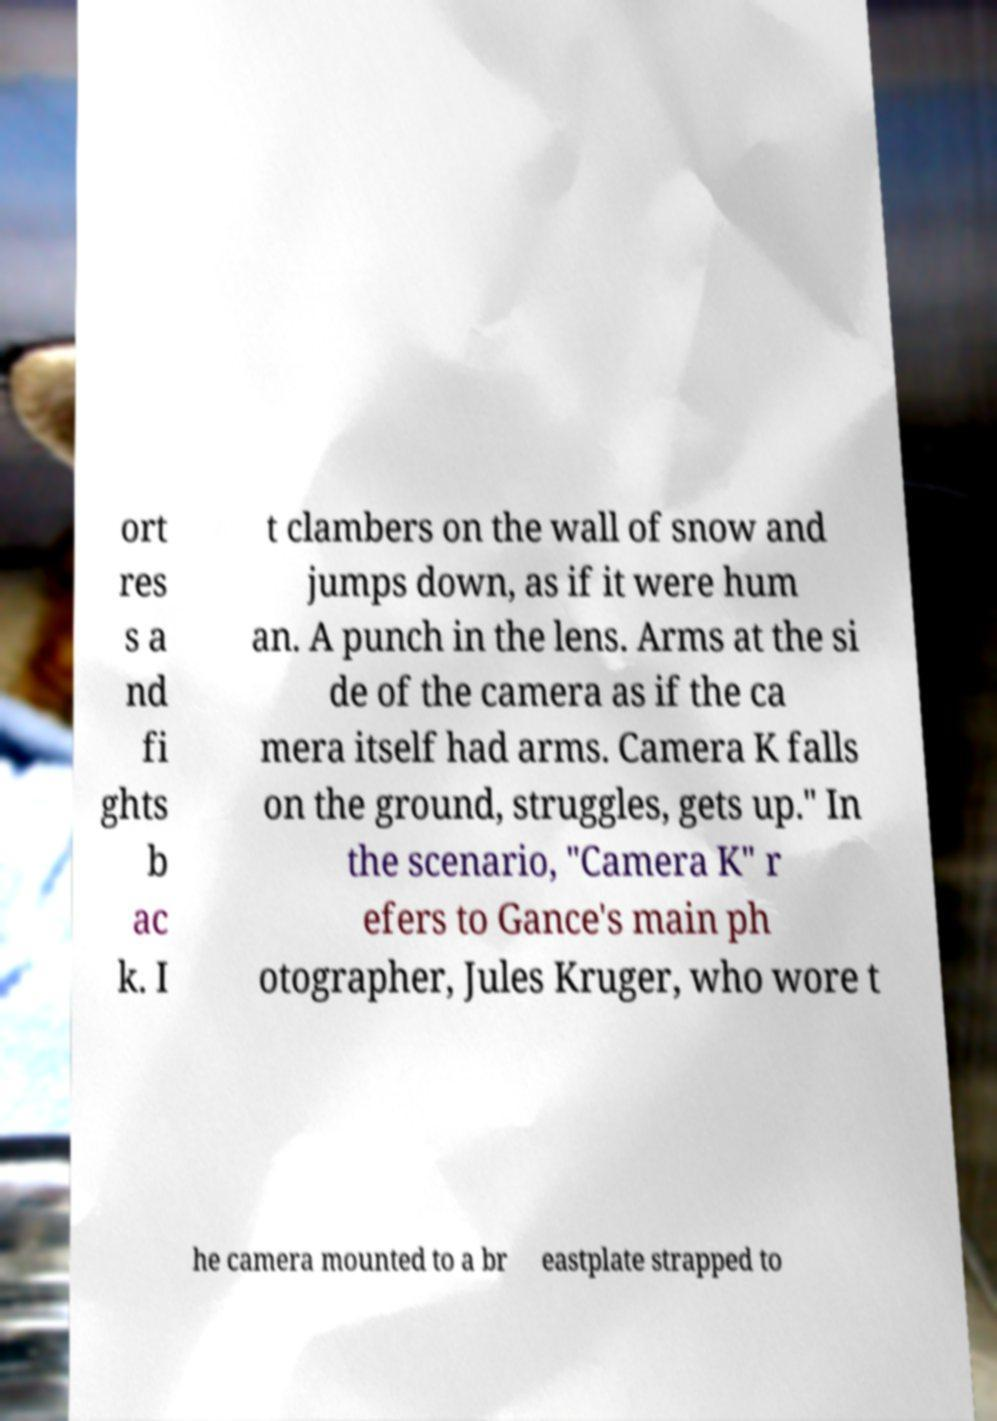For documentation purposes, I need the text within this image transcribed. Could you provide that? ort res s a nd fi ghts b ac k. I t clambers on the wall of snow and jumps down, as if it were hum an. A punch in the lens. Arms at the si de of the camera as if the ca mera itself had arms. Camera K falls on the ground, struggles, gets up." In the scenario, "Camera K" r efers to Gance's main ph otographer, Jules Kruger, who wore t he camera mounted to a br eastplate strapped to 